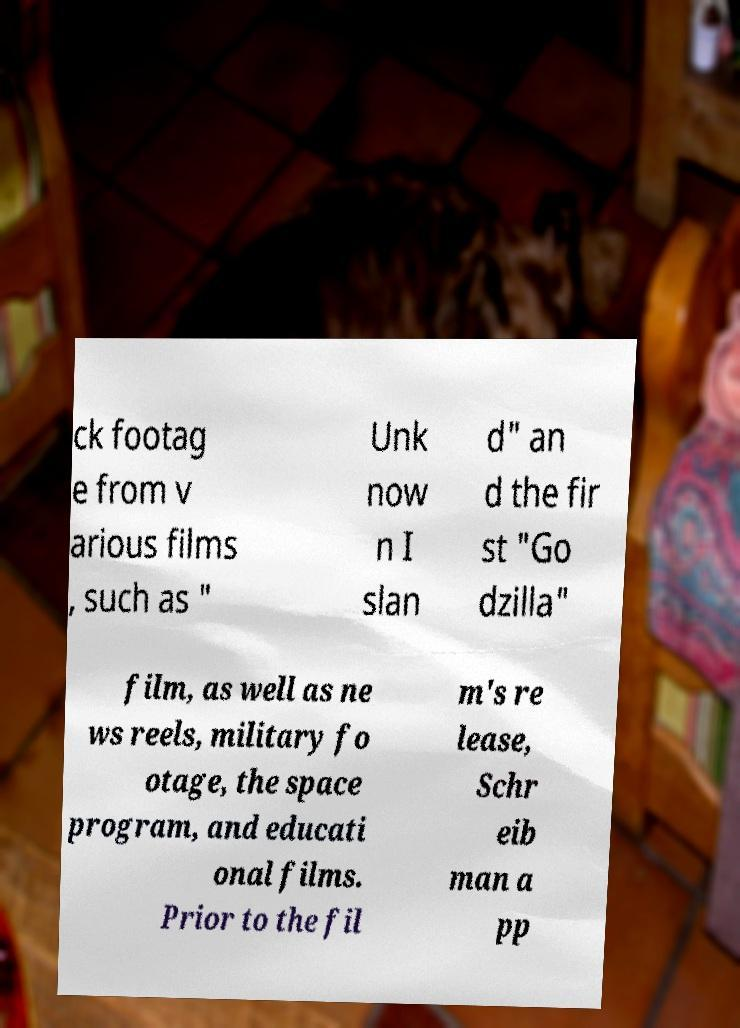For documentation purposes, I need the text within this image transcribed. Could you provide that? ck footag e from v arious films , such as " Unk now n I slan d" an d the fir st "Go dzilla" film, as well as ne ws reels, military fo otage, the space program, and educati onal films. Prior to the fil m's re lease, Schr eib man a pp 